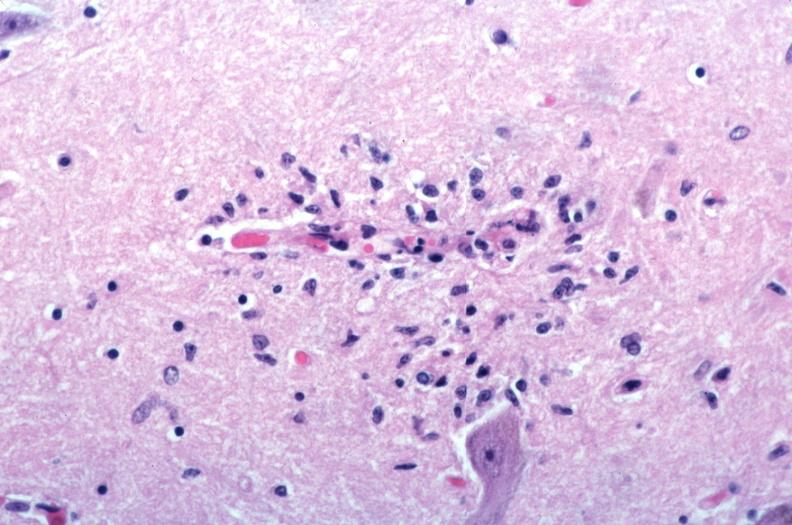s vasculitis due to rocky mountain spotted fever?
Answer the question using a single word or phrase. Yes 